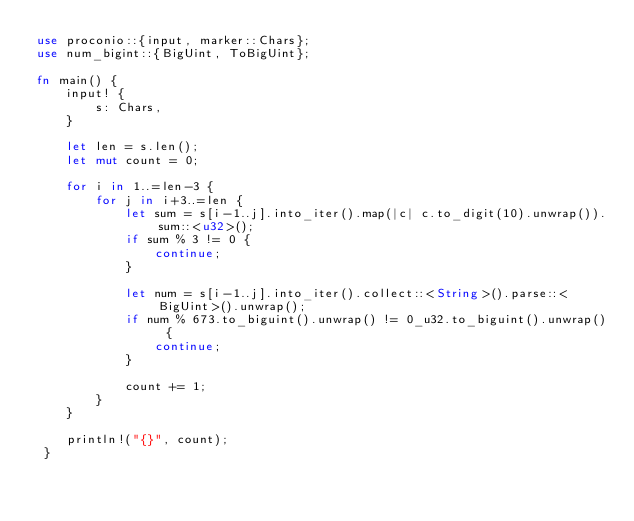Convert code to text. <code><loc_0><loc_0><loc_500><loc_500><_Rust_>use proconio::{input, marker::Chars};
use num_bigint::{BigUint, ToBigUint};

fn main() {
    input! {
        s: Chars,
    }

    let len = s.len();
    let mut count = 0;

    for i in 1..=len-3 {
        for j in i+3..=len {
            let sum = s[i-1..j].into_iter().map(|c| c.to_digit(10).unwrap()).sum::<u32>();
            if sum % 3 != 0 {
                continue;
            }

            let num = s[i-1..j].into_iter().collect::<String>().parse::<BigUint>().unwrap();
            if num % 673.to_biguint().unwrap() != 0_u32.to_biguint().unwrap() {
                continue;
            }

            count += 1;
        }
    }

    println!("{}", count);
 }
</code> 